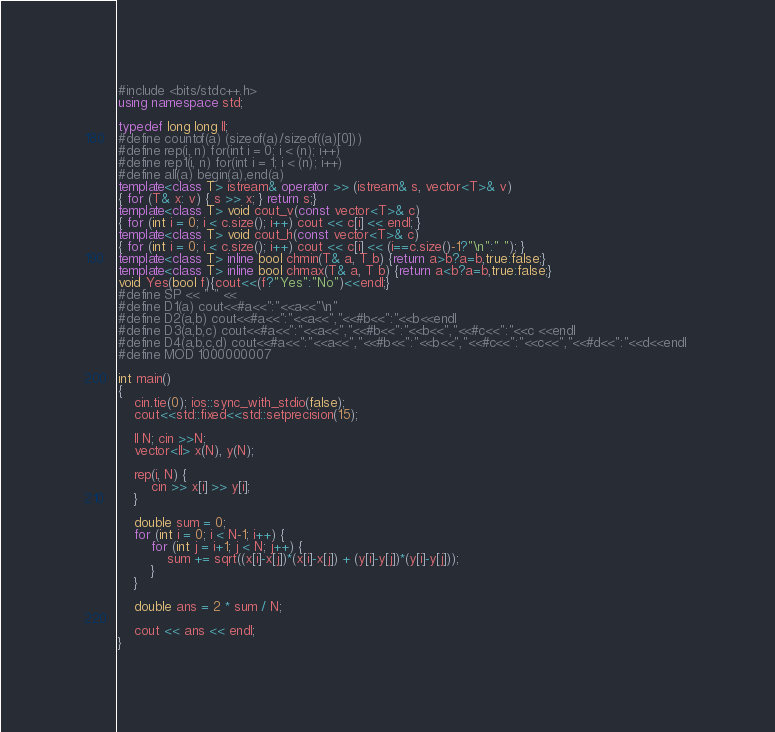Convert code to text. <code><loc_0><loc_0><loc_500><loc_500><_C++_>#include <bits/stdc++.h>
using namespace std;

typedef long long ll;
#define countof(a) (sizeof(a)/sizeof((a)[0]))
#define rep(i, n) for(int i = 0; i < (n); i++)
#define rep1(i, n) for(int i = 1; i < (n); i++)
#define all(a) begin(a),end(a)
template<class T> istream& operator >> (istream& s, vector<T>& v)
{ for (T& x: v) { s >> x; } return s;}
template<class T> void cout_v(const vector<T>& c)
{ for (int i = 0; i < c.size(); i++) cout << c[i] << endl; }
template<class T> void cout_h(const vector<T>& c)
{ for (int i = 0; i < c.size(); i++) cout << c[i] << (i==c.size()-1?"\n":" "); }
template<class T> inline bool chmin(T& a, T b) {return a>b?a=b,true:false;}
template<class T> inline bool chmax(T& a, T b) {return a<b?a=b,true:false;}
void Yes(bool f){cout<<(f?"Yes":"No")<<endl;}
#define SP << " " <<
#define D1(a) cout<<#a<<":"<<a<<"\n"
#define D2(a,b) cout<<#a<<":"<<a<<","<<#b<<":"<<b<<endl 
#define D3(a,b,c) cout<<#a<<":"<<a<<","<<#b<<":"<<b<<","<<#c<<":"<<c <<endl
#define D4(a,b,c,d) cout<<#a<<":"<<a<<","<<#b<<":"<<b<<","<<#c<<":"<<c<<","<<#d<<":"<<d<<endl 
#define MOD 1000000007

int main()
{
    cin.tie(0); ios::sync_with_stdio(false);
    cout<<std::fixed<<std::setprecision(15);

    ll N; cin >>N;
    vector<ll> x(N), y(N);
    
    rep(i, N) {
        cin >> x[i] >> y[i];
    }
    
    double sum = 0;
    for (int i = 0; i < N-1; i++) {
        for (int j = i+1; j < N; j++) {
            sum += sqrt((x[i]-x[j])*(x[i]-x[j]) + (y[i]-y[j])*(y[i]-y[j]));
        }
    }

    double ans = 2 * sum / N;

    cout << ans << endl;
}
</code> 